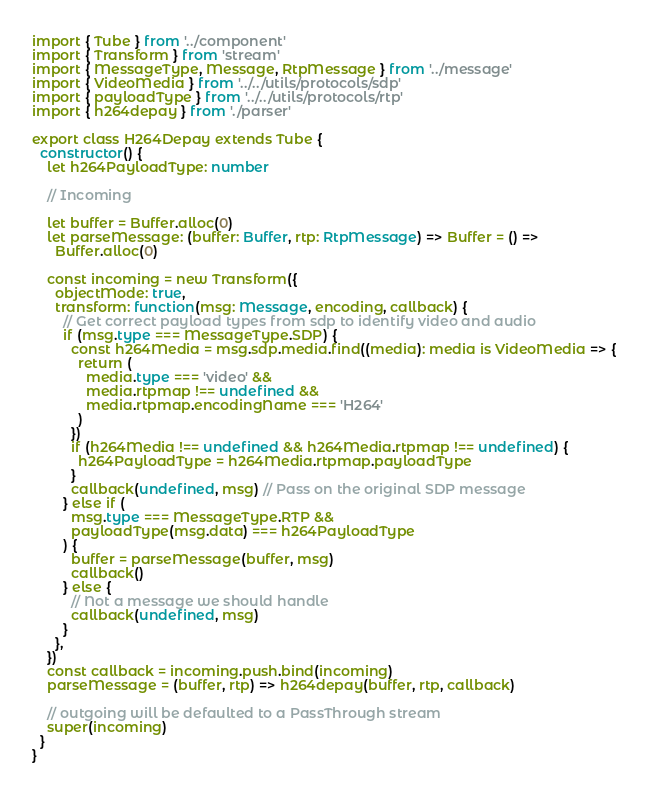<code> <loc_0><loc_0><loc_500><loc_500><_TypeScript_>import { Tube } from '../component'
import { Transform } from 'stream'
import { MessageType, Message, RtpMessage } from '../message'
import { VideoMedia } from '../../utils/protocols/sdp'
import { payloadType } from '../../utils/protocols/rtp'
import { h264depay } from './parser'

export class H264Depay extends Tube {
  constructor() {
    let h264PayloadType: number

    // Incoming

    let buffer = Buffer.alloc(0)
    let parseMessage: (buffer: Buffer, rtp: RtpMessage) => Buffer = () =>
      Buffer.alloc(0)

    const incoming = new Transform({
      objectMode: true,
      transform: function(msg: Message, encoding, callback) {
        // Get correct payload types from sdp to identify video and audio
        if (msg.type === MessageType.SDP) {
          const h264Media = msg.sdp.media.find((media): media is VideoMedia => {
            return (
              media.type === 'video' &&
              media.rtpmap !== undefined &&
              media.rtpmap.encodingName === 'H264'
            )
          })
          if (h264Media !== undefined && h264Media.rtpmap !== undefined) {
            h264PayloadType = h264Media.rtpmap.payloadType
          }
          callback(undefined, msg) // Pass on the original SDP message
        } else if (
          msg.type === MessageType.RTP &&
          payloadType(msg.data) === h264PayloadType
        ) {
          buffer = parseMessage(buffer, msg)
          callback()
        } else {
          // Not a message we should handle
          callback(undefined, msg)
        }
      },
    })
    const callback = incoming.push.bind(incoming)
    parseMessage = (buffer, rtp) => h264depay(buffer, rtp, callback)

    // outgoing will be defaulted to a PassThrough stream
    super(incoming)
  }
}
</code> 